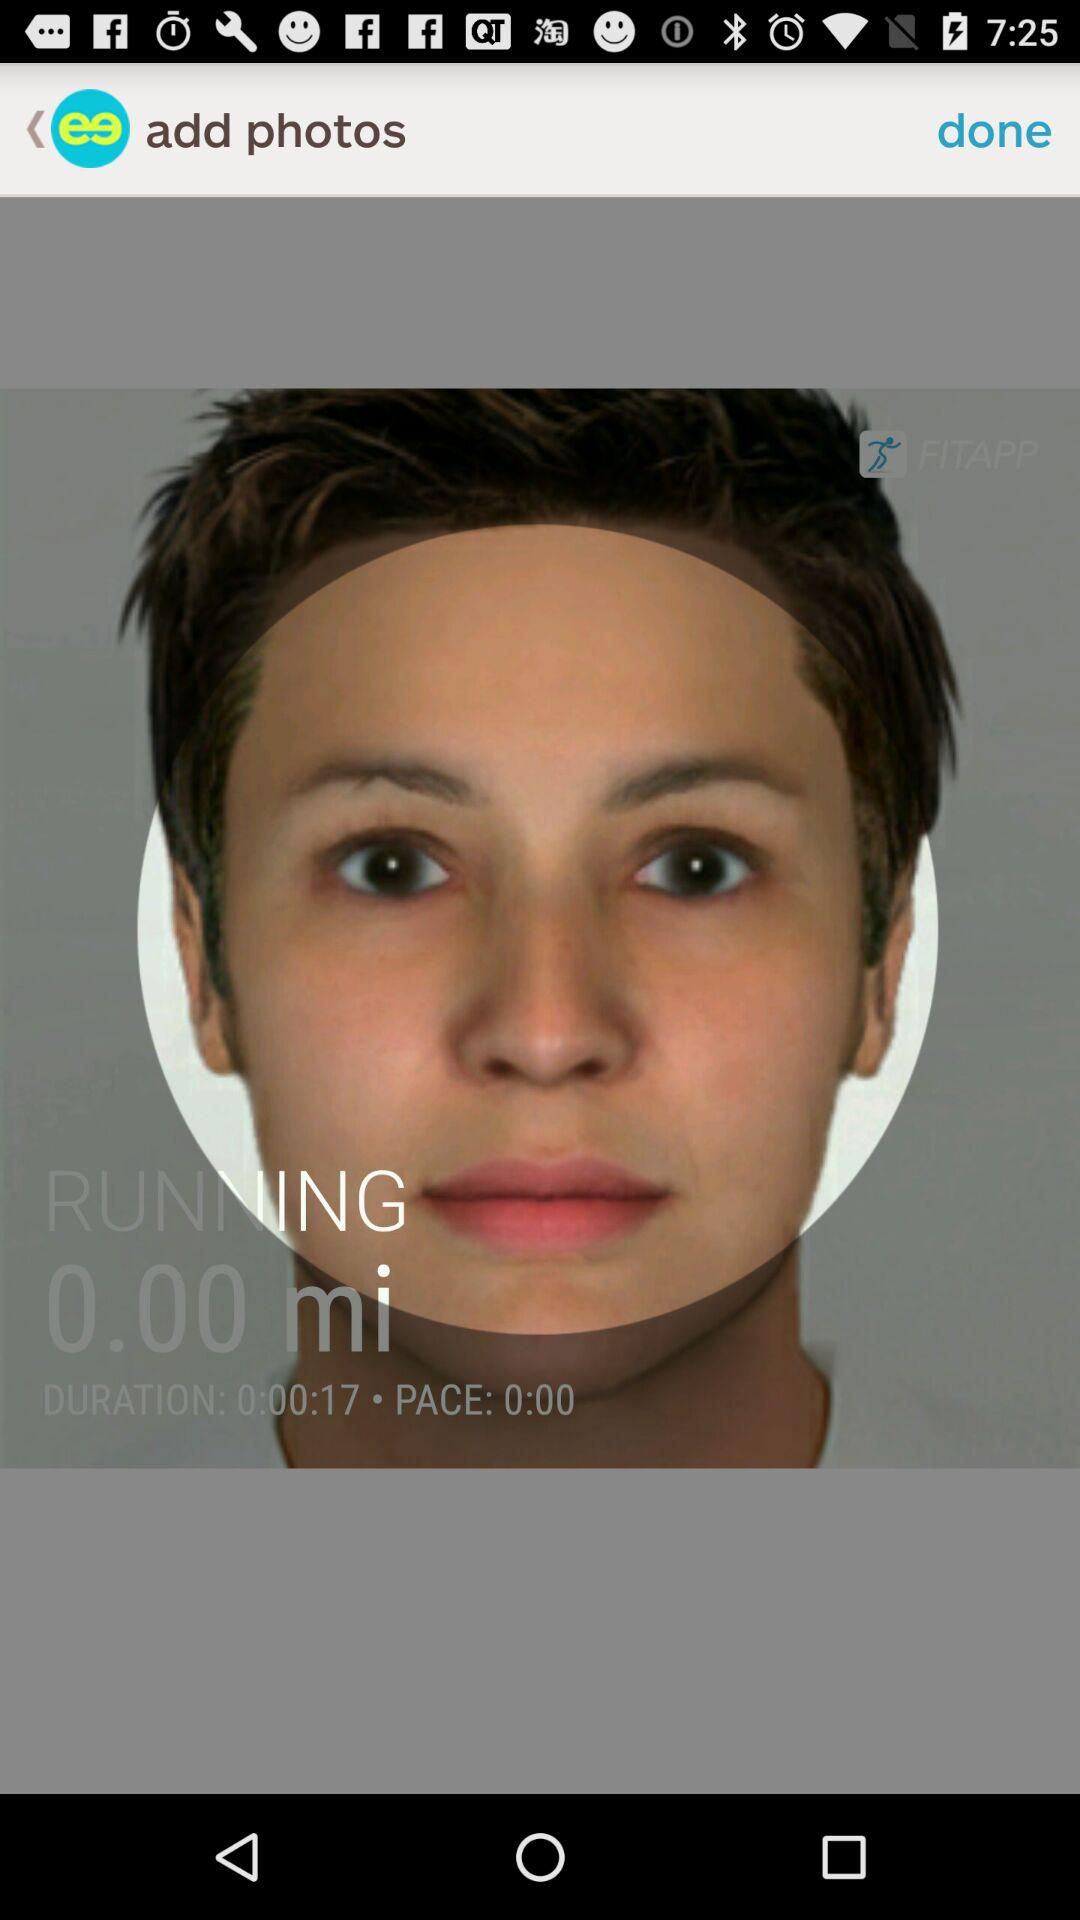What is the duration mentioned on the screen? The duration is 0:00:17. 